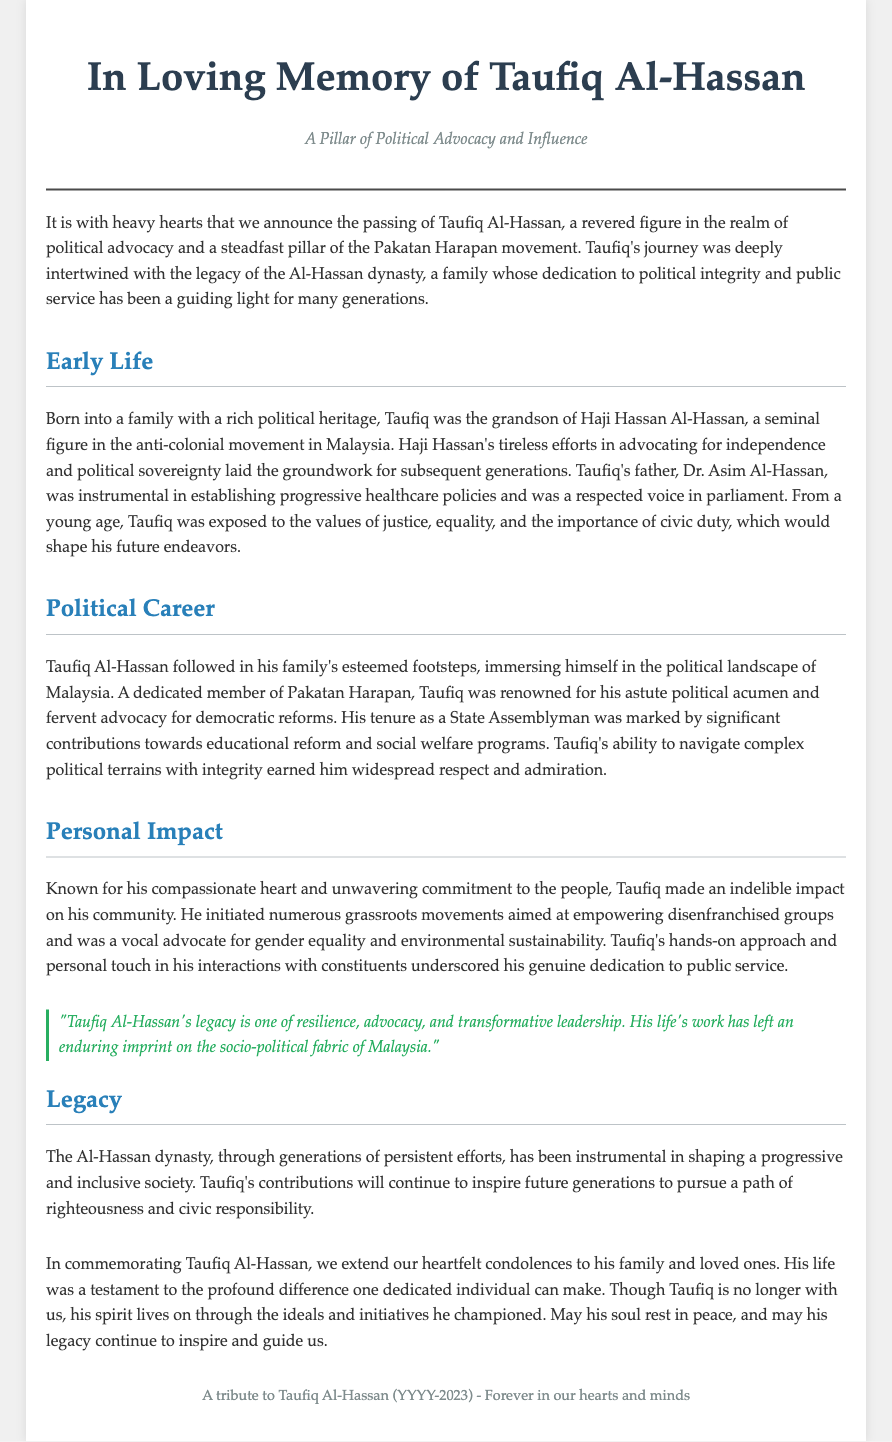What is the full name of the individual commemorated in this obituary? The obituary highlights Taufiq Al-Hassan as the individual being commemorated.
Answer: Taufiq Al-Hassan Who was Taufiq's grandfather? The document indicates that Taufiq's grandfather was Haji Hassan Al-Hassan, a key figure in the anti-colonial movement.
Answer: Haji Hassan Al-Hassan What notable position did Taufiq hold during his political career? The document states Taufiq served as a State Assemblyman, which is a significant role in Malaysian politics.
Answer: State Assemblyman What cause did Taufiq advocate for that relates to environmental issues? Taufiq was noted as a vocal advocate for environmental sustainability, indicating his commitment to this cause.
Answer: Environmental sustainability How did Taufiq's family contribute to his values? Taufiq's family instilled in him values of justice, equality, and civic duty, shaping his future endeavors.
Answer: Justice, equality, civic duty What year did Taufiq Al-Hassan pass away? The obituary specifies that he passed away in 2023, which is the most recent date mentioned.
Answer: 2023 What is the overarching legacy of the Al-Hassan dynasty described in the document? The legacy of the Al-Hassan dynasty is described as persistent efforts to shape a progressive and inclusive society.
Answer: Progressive and inclusive society What emotional tone is conveyed in Taufiq's obituary? The document conveys a tone of mourning and respect, emphasizing his impact and the heartfelt condolences extended to his family.
Answer: Mourning and respect 